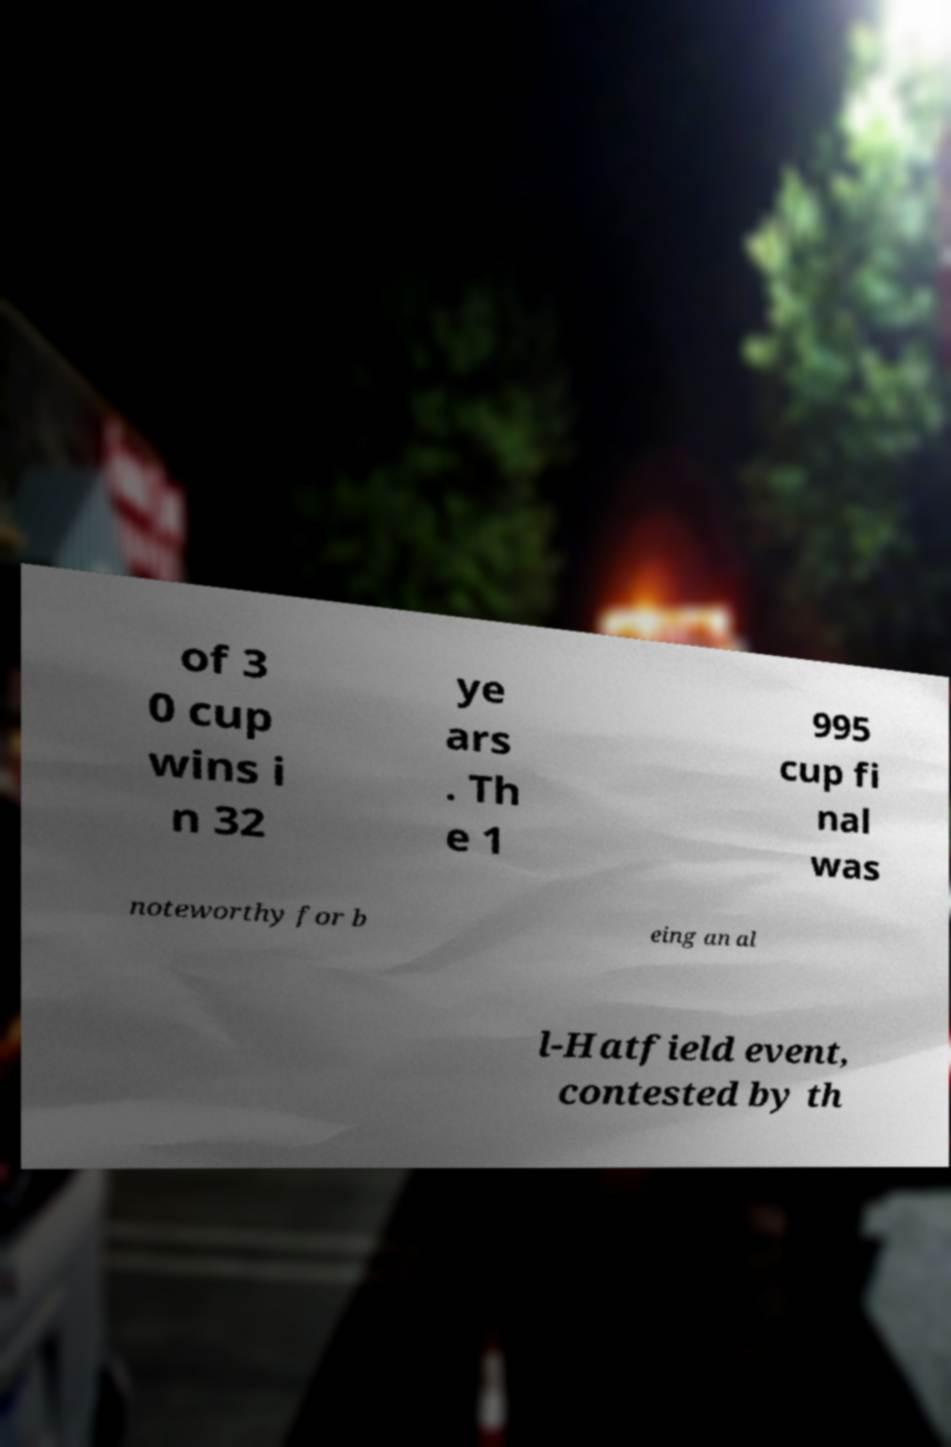There's text embedded in this image that I need extracted. Can you transcribe it verbatim? of 3 0 cup wins i n 32 ye ars . Th e 1 995 cup fi nal was noteworthy for b eing an al l-Hatfield event, contested by th 